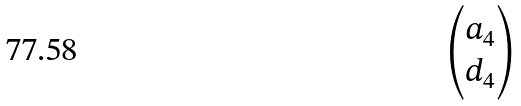<formula> <loc_0><loc_0><loc_500><loc_500>\begin{pmatrix} a _ { 4 } \\ d _ { 4 } \end{pmatrix}</formula> 